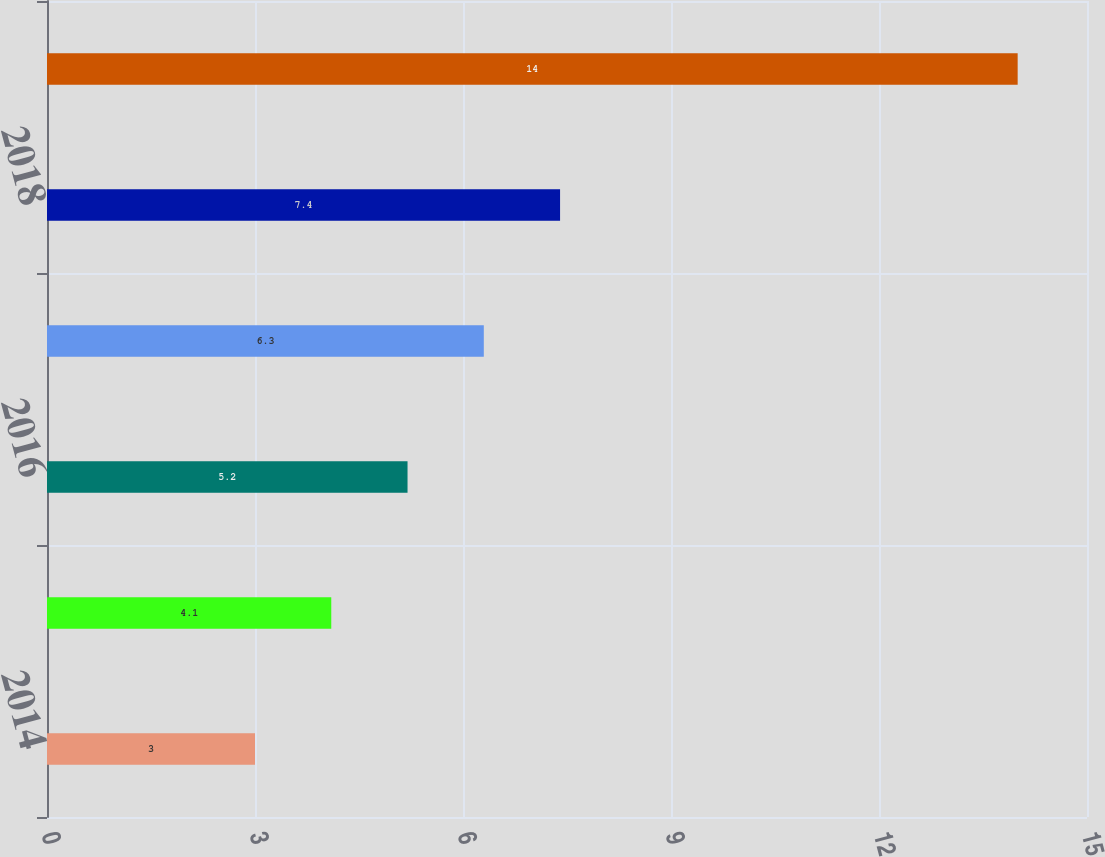<chart> <loc_0><loc_0><loc_500><loc_500><bar_chart><fcel>2014<fcel>2015<fcel>2016<fcel>2017<fcel>2018<fcel>2019 - 2023<nl><fcel>3<fcel>4.1<fcel>5.2<fcel>6.3<fcel>7.4<fcel>14<nl></chart> 